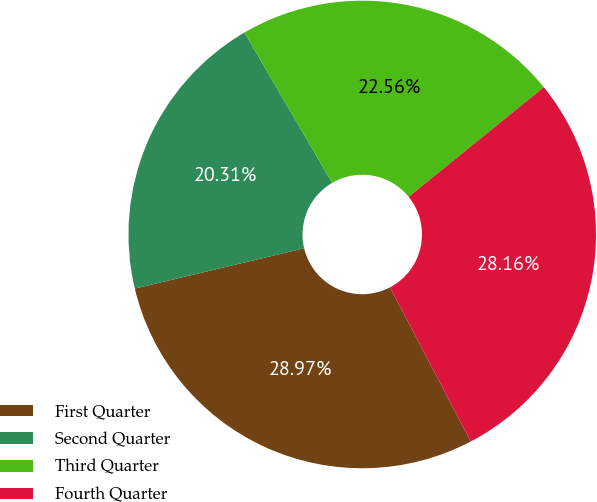Convert chart. <chart><loc_0><loc_0><loc_500><loc_500><pie_chart><fcel>First Quarter<fcel>Second Quarter<fcel>Third Quarter<fcel>Fourth Quarter<nl><fcel>28.97%<fcel>20.31%<fcel>22.56%<fcel>28.16%<nl></chart> 